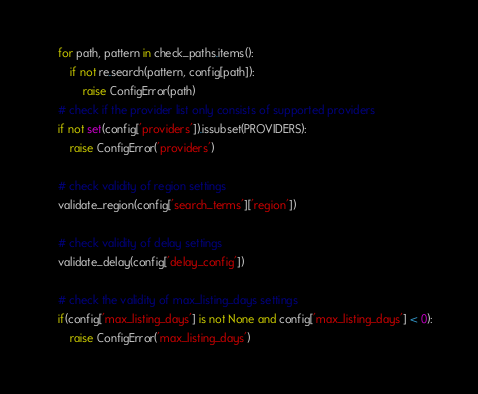Convert code to text. <code><loc_0><loc_0><loc_500><loc_500><_Python_>
    for path, pattern in check_paths.items():
        if not re.search(pattern, config[path]):
            raise ConfigError(path)
    # check if the provider list only consists of supported providers
    if not set(config['providers']).issubset(PROVIDERS):
        raise ConfigError('providers')

    # check validity of region settings
    validate_region(config['search_terms']['region'])

    # check validity of delay settings
    validate_delay(config['delay_config'])

    # check the validity of max_listing_days settings
    if(config['max_listing_days'] is not None and config['max_listing_days'] < 0):
        raise ConfigError('max_listing_days')
</code> 